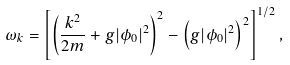<formula> <loc_0><loc_0><loc_500><loc_500>\omega _ { k } = \left [ \left ( \frac { k ^ { 2 } } { 2 m } + g | \phi _ { 0 } | ^ { 2 } \right ) ^ { 2 } - \left ( g | \phi _ { 0 } | ^ { 2 } \right ) ^ { 2 } \right ] ^ { 1 / 2 } ,</formula> 